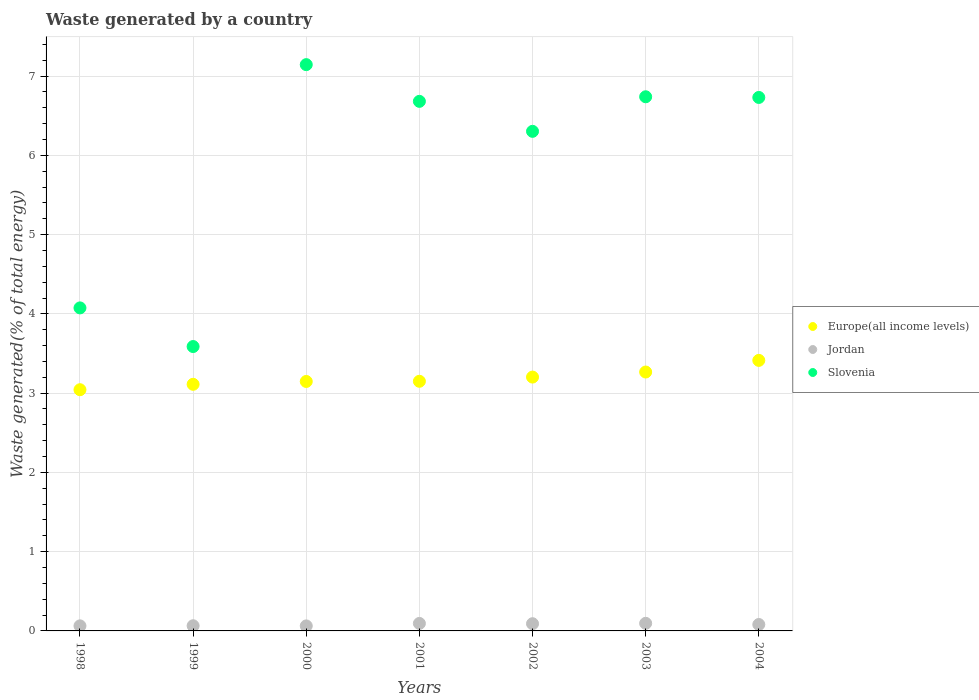Is the number of dotlines equal to the number of legend labels?
Give a very brief answer. Yes. What is the total waste generated in Slovenia in 2002?
Ensure brevity in your answer.  6.3. Across all years, what is the maximum total waste generated in Jordan?
Keep it short and to the point. 0.1. Across all years, what is the minimum total waste generated in Jordan?
Make the answer very short. 0.06. In which year was the total waste generated in Europe(all income levels) maximum?
Provide a short and direct response. 2004. In which year was the total waste generated in Europe(all income levels) minimum?
Give a very brief answer. 1998. What is the total total waste generated in Jordan in the graph?
Offer a terse response. 0.55. What is the difference between the total waste generated in Europe(all income levels) in 1998 and that in 2004?
Your answer should be compact. -0.37. What is the difference between the total waste generated in Europe(all income levels) in 1998 and the total waste generated in Slovenia in 2001?
Provide a short and direct response. -3.64. What is the average total waste generated in Jordan per year?
Your response must be concise. 0.08. In the year 2001, what is the difference between the total waste generated in Jordan and total waste generated in Europe(all income levels)?
Provide a succinct answer. -3.06. What is the ratio of the total waste generated in Slovenia in 2003 to that in 2004?
Provide a succinct answer. 1. Is the total waste generated in Jordan in 1999 less than that in 2003?
Your response must be concise. Yes. What is the difference between the highest and the second highest total waste generated in Jordan?
Your answer should be very brief. 0. What is the difference between the highest and the lowest total waste generated in Europe(all income levels)?
Ensure brevity in your answer.  0.37. In how many years, is the total waste generated in Jordan greater than the average total waste generated in Jordan taken over all years?
Your response must be concise. 4. Is the sum of the total waste generated in Jordan in 2001 and 2003 greater than the maximum total waste generated in Slovenia across all years?
Keep it short and to the point. No. Is it the case that in every year, the sum of the total waste generated in Europe(all income levels) and total waste generated in Slovenia  is greater than the total waste generated in Jordan?
Ensure brevity in your answer.  Yes. Does the total waste generated in Slovenia monotonically increase over the years?
Ensure brevity in your answer.  No. Is the total waste generated in Jordan strictly greater than the total waste generated in Europe(all income levels) over the years?
Keep it short and to the point. No. How many dotlines are there?
Your answer should be compact. 3. What is the difference between two consecutive major ticks on the Y-axis?
Your answer should be compact. 1. Are the values on the major ticks of Y-axis written in scientific E-notation?
Give a very brief answer. No. Does the graph contain any zero values?
Provide a short and direct response. No. Does the graph contain grids?
Make the answer very short. Yes. How many legend labels are there?
Offer a very short reply. 3. How are the legend labels stacked?
Offer a very short reply. Vertical. What is the title of the graph?
Provide a succinct answer. Waste generated by a country. What is the label or title of the Y-axis?
Your response must be concise. Waste generated(% of total energy). What is the Waste generated(% of total energy) of Europe(all income levels) in 1998?
Keep it short and to the point. 3.04. What is the Waste generated(% of total energy) of Jordan in 1998?
Make the answer very short. 0.06. What is the Waste generated(% of total energy) in Slovenia in 1998?
Ensure brevity in your answer.  4.08. What is the Waste generated(% of total energy) in Europe(all income levels) in 1999?
Give a very brief answer. 3.11. What is the Waste generated(% of total energy) in Jordan in 1999?
Keep it short and to the point. 0.07. What is the Waste generated(% of total energy) in Slovenia in 1999?
Make the answer very short. 3.59. What is the Waste generated(% of total energy) in Europe(all income levels) in 2000?
Your answer should be compact. 3.15. What is the Waste generated(% of total energy) of Jordan in 2000?
Ensure brevity in your answer.  0.06. What is the Waste generated(% of total energy) in Slovenia in 2000?
Ensure brevity in your answer.  7.14. What is the Waste generated(% of total energy) of Europe(all income levels) in 2001?
Offer a terse response. 3.15. What is the Waste generated(% of total energy) of Jordan in 2001?
Your response must be concise. 0.09. What is the Waste generated(% of total energy) in Slovenia in 2001?
Your answer should be compact. 6.68. What is the Waste generated(% of total energy) in Europe(all income levels) in 2002?
Provide a short and direct response. 3.2. What is the Waste generated(% of total energy) in Jordan in 2002?
Keep it short and to the point. 0.09. What is the Waste generated(% of total energy) in Slovenia in 2002?
Provide a succinct answer. 6.3. What is the Waste generated(% of total energy) in Europe(all income levels) in 2003?
Offer a very short reply. 3.27. What is the Waste generated(% of total energy) in Jordan in 2003?
Offer a very short reply. 0.1. What is the Waste generated(% of total energy) of Slovenia in 2003?
Give a very brief answer. 6.74. What is the Waste generated(% of total energy) of Europe(all income levels) in 2004?
Your response must be concise. 3.41. What is the Waste generated(% of total energy) of Jordan in 2004?
Your answer should be very brief. 0.08. What is the Waste generated(% of total energy) of Slovenia in 2004?
Provide a short and direct response. 6.73. Across all years, what is the maximum Waste generated(% of total energy) of Europe(all income levels)?
Make the answer very short. 3.41. Across all years, what is the maximum Waste generated(% of total energy) in Jordan?
Ensure brevity in your answer.  0.1. Across all years, what is the maximum Waste generated(% of total energy) in Slovenia?
Your answer should be compact. 7.14. Across all years, what is the minimum Waste generated(% of total energy) in Europe(all income levels)?
Your answer should be very brief. 3.04. Across all years, what is the minimum Waste generated(% of total energy) of Jordan?
Provide a succinct answer. 0.06. Across all years, what is the minimum Waste generated(% of total energy) of Slovenia?
Your answer should be very brief. 3.59. What is the total Waste generated(% of total energy) of Europe(all income levels) in the graph?
Ensure brevity in your answer.  22.33. What is the total Waste generated(% of total energy) of Jordan in the graph?
Your answer should be compact. 0.55. What is the total Waste generated(% of total energy) of Slovenia in the graph?
Your answer should be compact. 41.26. What is the difference between the Waste generated(% of total energy) of Europe(all income levels) in 1998 and that in 1999?
Give a very brief answer. -0.07. What is the difference between the Waste generated(% of total energy) of Jordan in 1998 and that in 1999?
Your response must be concise. -0. What is the difference between the Waste generated(% of total energy) in Slovenia in 1998 and that in 1999?
Your answer should be compact. 0.49. What is the difference between the Waste generated(% of total energy) of Europe(all income levels) in 1998 and that in 2000?
Provide a succinct answer. -0.1. What is the difference between the Waste generated(% of total energy) of Jordan in 1998 and that in 2000?
Your answer should be very brief. 0. What is the difference between the Waste generated(% of total energy) of Slovenia in 1998 and that in 2000?
Your answer should be very brief. -3.07. What is the difference between the Waste generated(% of total energy) of Europe(all income levels) in 1998 and that in 2001?
Provide a short and direct response. -0.11. What is the difference between the Waste generated(% of total energy) in Jordan in 1998 and that in 2001?
Offer a very short reply. -0.03. What is the difference between the Waste generated(% of total energy) of Slovenia in 1998 and that in 2001?
Ensure brevity in your answer.  -2.61. What is the difference between the Waste generated(% of total energy) in Europe(all income levels) in 1998 and that in 2002?
Provide a short and direct response. -0.16. What is the difference between the Waste generated(% of total energy) of Jordan in 1998 and that in 2002?
Provide a succinct answer. -0.03. What is the difference between the Waste generated(% of total energy) in Slovenia in 1998 and that in 2002?
Make the answer very short. -2.23. What is the difference between the Waste generated(% of total energy) of Europe(all income levels) in 1998 and that in 2003?
Offer a very short reply. -0.22. What is the difference between the Waste generated(% of total energy) in Jordan in 1998 and that in 2003?
Make the answer very short. -0.03. What is the difference between the Waste generated(% of total energy) in Slovenia in 1998 and that in 2003?
Keep it short and to the point. -2.66. What is the difference between the Waste generated(% of total energy) of Europe(all income levels) in 1998 and that in 2004?
Provide a succinct answer. -0.37. What is the difference between the Waste generated(% of total energy) of Jordan in 1998 and that in 2004?
Your response must be concise. -0.02. What is the difference between the Waste generated(% of total energy) in Slovenia in 1998 and that in 2004?
Ensure brevity in your answer.  -2.66. What is the difference between the Waste generated(% of total energy) in Europe(all income levels) in 1999 and that in 2000?
Your answer should be compact. -0.04. What is the difference between the Waste generated(% of total energy) of Jordan in 1999 and that in 2000?
Provide a succinct answer. 0. What is the difference between the Waste generated(% of total energy) of Slovenia in 1999 and that in 2000?
Your response must be concise. -3.56. What is the difference between the Waste generated(% of total energy) in Europe(all income levels) in 1999 and that in 2001?
Make the answer very short. -0.04. What is the difference between the Waste generated(% of total energy) in Jordan in 1999 and that in 2001?
Provide a succinct answer. -0.03. What is the difference between the Waste generated(% of total energy) in Slovenia in 1999 and that in 2001?
Offer a terse response. -3.09. What is the difference between the Waste generated(% of total energy) of Europe(all income levels) in 1999 and that in 2002?
Make the answer very short. -0.09. What is the difference between the Waste generated(% of total energy) of Jordan in 1999 and that in 2002?
Offer a terse response. -0.03. What is the difference between the Waste generated(% of total energy) in Slovenia in 1999 and that in 2002?
Give a very brief answer. -2.72. What is the difference between the Waste generated(% of total energy) of Europe(all income levels) in 1999 and that in 2003?
Your response must be concise. -0.15. What is the difference between the Waste generated(% of total energy) of Jordan in 1999 and that in 2003?
Keep it short and to the point. -0.03. What is the difference between the Waste generated(% of total energy) in Slovenia in 1999 and that in 2003?
Provide a succinct answer. -3.15. What is the difference between the Waste generated(% of total energy) in Europe(all income levels) in 1999 and that in 2004?
Your response must be concise. -0.3. What is the difference between the Waste generated(% of total energy) of Jordan in 1999 and that in 2004?
Provide a succinct answer. -0.02. What is the difference between the Waste generated(% of total energy) in Slovenia in 1999 and that in 2004?
Make the answer very short. -3.14. What is the difference between the Waste generated(% of total energy) in Europe(all income levels) in 2000 and that in 2001?
Keep it short and to the point. -0. What is the difference between the Waste generated(% of total energy) in Jordan in 2000 and that in 2001?
Your response must be concise. -0.03. What is the difference between the Waste generated(% of total energy) in Slovenia in 2000 and that in 2001?
Your response must be concise. 0.46. What is the difference between the Waste generated(% of total energy) in Europe(all income levels) in 2000 and that in 2002?
Your response must be concise. -0.06. What is the difference between the Waste generated(% of total energy) of Jordan in 2000 and that in 2002?
Make the answer very short. -0.03. What is the difference between the Waste generated(% of total energy) of Slovenia in 2000 and that in 2002?
Offer a very short reply. 0.84. What is the difference between the Waste generated(% of total energy) of Europe(all income levels) in 2000 and that in 2003?
Ensure brevity in your answer.  -0.12. What is the difference between the Waste generated(% of total energy) in Jordan in 2000 and that in 2003?
Give a very brief answer. -0.03. What is the difference between the Waste generated(% of total energy) in Slovenia in 2000 and that in 2003?
Offer a terse response. 0.41. What is the difference between the Waste generated(% of total energy) in Europe(all income levels) in 2000 and that in 2004?
Provide a succinct answer. -0.27. What is the difference between the Waste generated(% of total energy) in Jordan in 2000 and that in 2004?
Provide a short and direct response. -0.02. What is the difference between the Waste generated(% of total energy) of Slovenia in 2000 and that in 2004?
Your answer should be very brief. 0.41. What is the difference between the Waste generated(% of total energy) of Europe(all income levels) in 2001 and that in 2002?
Keep it short and to the point. -0.05. What is the difference between the Waste generated(% of total energy) of Jordan in 2001 and that in 2002?
Provide a succinct answer. 0. What is the difference between the Waste generated(% of total energy) of Slovenia in 2001 and that in 2002?
Offer a very short reply. 0.38. What is the difference between the Waste generated(% of total energy) of Europe(all income levels) in 2001 and that in 2003?
Provide a succinct answer. -0.12. What is the difference between the Waste generated(% of total energy) in Jordan in 2001 and that in 2003?
Offer a very short reply. -0. What is the difference between the Waste generated(% of total energy) of Slovenia in 2001 and that in 2003?
Provide a short and direct response. -0.06. What is the difference between the Waste generated(% of total energy) in Europe(all income levels) in 2001 and that in 2004?
Offer a very short reply. -0.26. What is the difference between the Waste generated(% of total energy) of Jordan in 2001 and that in 2004?
Your answer should be very brief. 0.01. What is the difference between the Waste generated(% of total energy) of Slovenia in 2001 and that in 2004?
Your response must be concise. -0.05. What is the difference between the Waste generated(% of total energy) of Europe(all income levels) in 2002 and that in 2003?
Give a very brief answer. -0.06. What is the difference between the Waste generated(% of total energy) in Jordan in 2002 and that in 2003?
Make the answer very short. -0. What is the difference between the Waste generated(% of total energy) of Slovenia in 2002 and that in 2003?
Your answer should be very brief. -0.44. What is the difference between the Waste generated(% of total energy) of Europe(all income levels) in 2002 and that in 2004?
Provide a succinct answer. -0.21. What is the difference between the Waste generated(% of total energy) in Slovenia in 2002 and that in 2004?
Your answer should be very brief. -0.43. What is the difference between the Waste generated(% of total energy) of Europe(all income levels) in 2003 and that in 2004?
Offer a very short reply. -0.15. What is the difference between the Waste generated(% of total energy) of Jordan in 2003 and that in 2004?
Your answer should be compact. 0.01. What is the difference between the Waste generated(% of total energy) of Slovenia in 2003 and that in 2004?
Offer a terse response. 0.01. What is the difference between the Waste generated(% of total energy) in Europe(all income levels) in 1998 and the Waste generated(% of total energy) in Jordan in 1999?
Offer a very short reply. 2.98. What is the difference between the Waste generated(% of total energy) in Europe(all income levels) in 1998 and the Waste generated(% of total energy) in Slovenia in 1999?
Provide a succinct answer. -0.54. What is the difference between the Waste generated(% of total energy) of Jordan in 1998 and the Waste generated(% of total energy) of Slovenia in 1999?
Your response must be concise. -3.52. What is the difference between the Waste generated(% of total energy) of Europe(all income levels) in 1998 and the Waste generated(% of total energy) of Jordan in 2000?
Ensure brevity in your answer.  2.98. What is the difference between the Waste generated(% of total energy) of Europe(all income levels) in 1998 and the Waste generated(% of total energy) of Slovenia in 2000?
Give a very brief answer. -4.1. What is the difference between the Waste generated(% of total energy) of Jordan in 1998 and the Waste generated(% of total energy) of Slovenia in 2000?
Give a very brief answer. -7.08. What is the difference between the Waste generated(% of total energy) of Europe(all income levels) in 1998 and the Waste generated(% of total energy) of Jordan in 2001?
Provide a short and direct response. 2.95. What is the difference between the Waste generated(% of total energy) in Europe(all income levels) in 1998 and the Waste generated(% of total energy) in Slovenia in 2001?
Your response must be concise. -3.64. What is the difference between the Waste generated(% of total energy) of Jordan in 1998 and the Waste generated(% of total energy) of Slovenia in 2001?
Provide a succinct answer. -6.62. What is the difference between the Waste generated(% of total energy) in Europe(all income levels) in 1998 and the Waste generated(% of total energy) in Jordan in 2002?
Your response must be concise. 2.95. What is the difference between the Waste generated(% of total energy) of Europe(all income levels) in 1998 and the Waste generated(% of total energy) of Slovenia in 2002?
Give a very brief answer. -3.26. What is the difference between the Waste generated(% of total energy) in Jordan in 1998 and the Waste generated(% of total energy) in Slovenia in 2002?
Your response must be concise. -6.24. What is the difference between the Waste generated(% of total energy) of Europe(all income levels) in 1998 and the Waste generated(% of total energy) of Jordan in 2003?
Offer a very short reply. 2.95. What is the difference between the Waste generated(% of total energy) of Europe(all income levels) in 1998 and the Waste generated(% of total energy) of Slovenia in 2003?
Make the answer very short. -3.7. What is the difference between the Waste generated(% of total energy) in Jordan in 1998 and the Waste generated(% of total energy) in Slovenia in 2003?
Keep it short and to the point. -6.68. What is the difference between the Waste generated(% of total energy) in Europe(all income levels) in 1998 and the Waste generated(% of total energy) in Jordan in 2004?
Your response must be concise. 2.96. What is the difference between the Waste generated(% of total energy) in Europe(all income levels) in 1998 and the Waste generated(% of total energy) in Slovenia in 2004?
Your answer should be very brief. -3.69. What is the difference between the Waste generated(% of total energy) in Jordan in 1998 and the Waste generated(% of total energy) in Slovenia in 2004?
Keep it short and to the point. -6.67. What is the difference between the Waste generated(% of total energy) of Europe(all income levels) in 1999 and the Waste generated(% of total energy) of Jordan in 2000?
Make the answer very short. 3.05. What is the difference between the Waste generated(% of total energy) in Europe(all income levels) in 1999 and the Waste generated(% of total energy) in Slovenia in 2000?
Your answer should be very brief. -4.03. What is the difference between the Waste generated(% of total energy) in Jordan in 1999 and the Waste generated(% of total energy) in Slovenia in 2000?
Make the answer very short. -7.08. What is the difference between the Waste generated(% of total energy) in Europe(all income levels) in 1999 and the Waste generated(% of total energy) in Jordan in 2001?
Your answer should be very brief. 3.02. What is the difference between the Waste generated(% of total energy) in Europe(all income levels) in 1999 and the Waste generated(% of total energy) in Slovenia in 2001?
Offer a very short reply. -3.57. What is the difference between the Waste generated(% of total energy) in Jordan in 1999 and the Waste generated(% of total energy) in Slovenia in 2001?
Provide a short and direct response. -6.62. What is the difference between the Waste generated(% of total energy) of Europe(all income levels) in 1999 and the Waste generated(% of total energy) of Jordan in 2002?
Provide a short and direct response. 3.02. What is the difference between the Waste generated(% of total energy) of Europe(all income levels) in 1999 and the Waste generated(% of total energy) of Slovenia in 2002?
Ensure brevity in your answer.  -3.19. What is the difference between the Waste generated(% of total energy) of Jordan in 1999 and the Waste generated(% of total energy) of Slovenia in 2002?
Offer a very short reply. -6.24. What is the difference between the Waste generated(% of total energy) in Europe(all income levels) in 1999 and the Waste generated(% of total energy) in Jordan in 2003?
Give a very brief answer. 3.02. What is the difference between the Waste generated(% of total energy) of Europe(all income levels) in 1999 and the Waste generated(% of total energy) of Slovenia in 2003?
Give a very brief answer. -3.63. What is the difference between the Waste generated(% of total energy) of Jordan in 1999 and the Waste generated(% of total energy) of Slovenia in 2003?
Ensure brevity in your answer.  -6.67. What is the difference between the Waste generated(% of total energy) in Europe(all income levels) in 1999 and the Waste generated(% of total energy) in Jordan in 2004?
Provide a short and direct response. 3.03. What is the difference between the Waste generated(% of total energy) in Europe(all income levels) in 1999 and the Waste generated(% of total energy) in Slovenia in 2004?
Offer a terse response. -3.62. What is the difference between the Waste generated(% of total energy) in Jordan in 1999 and the Waste generated(% of total energy) in Slovenia in 2004?
Your response must be concise. -6.67. What is the difference between the Waste generated(% of total energy) in Europe(all income levels) in 2000 and the Waste generated(% of total energy) in Jordan in 2001?
Provide a succinct answer. 3.05. What is the difference between the Waste generated(% of total energy) of Europe(all income levels) in 2000 and the Waste generated(% of total energy) of Slovenia in 2001?
Your answer should be compact. -3.53. What is the difference between the Waste generated(% of total energy) in Jordan in 2000 and the Waste generated(% of total energy) in Slovenia in 2001?
Ensure brevity in your answer.  -6.62. What is the difference between the Waste generated(% of total energy) in Europe(all income levels) in 2000 and the Waste generated(% of total energy) in Jordan in 2002?
Your answer should be compact. 3.06. What is the difference between the Waste generated(% of total energy) of Europe(all income levels) in 2000 and the Waste generated(% of total energy) of Slovenia in 2002?
Keep it short and to the point. -3.16. What is the difference between the Waste generated(% of total energy) in Jordan in 2000 and the Waste generated(% of total energy) in Slovenia in 2002?
Provide a succinct answer. -6.24. What is the difference between the Waste generated(% of total energy) in Europe(all income levels) in 2000 and the Waste generated(% of total energy) in Jordan in 2003?
Provide a short and direct response. 3.05. What is the difference between the Waste generated(% of total energy) of Europe(all income levels) in 2000 and the Waste generated(% of total energy) of Slovenia in 2003?
Make the answer very short. -3.59. What is the difference between the Waste generated(% of total energy) of Jordan in 2000 and the Waste generated(% of total energy) of Slovenia in 2003?
Make the answer very short. -6.68. What is the difference between the Waste generated(% of total energy) of Europe(all income levels) in 2000 and the Waste generated(% of total energy) of Jordan in 2004?
Your answer should be compact. 3.07. What is the difference between the Waste generated(% of total energy) in Europe(all income levels) in 2000 and the Waste generated(% of total energy) in Slovenia in 2004?
Your response must be concise. -3.58. What is the difference between the Waste generated(% of total energy) in Jordan in 2000 and the Waste generated(% of total energy) in Slovenia in 2004?
Offer a very short reply. -6.67. What is the difference between the Waste generated(% of total energy) in Europe(all income levels) in 2001 and the Waste generated(% of total energy) in Jordan in 2002?
Provide a succinct answer. 3.06. What is the difference between the Waste generated(% of total energy) in Europe(all income levels) in 2001 and the Waste generated(% of total energy) in Slovenia in 2002?
Provide a short and direct response. -3.15. What is the difference between the Waste generated(% of total energy) in Jordan in 2001 and the Waste generated(% of total energy) in Slovenia in 2002?
Make the answer very short. -6.21. What is the difference between the Waste generated(% of total energy) in Europe(all income levels) in 2001 and the Waste generated(% of total energy) in Jordan in 2003?
Provide a short and direct response. 3.05. What is the difference between the Waste generated(% of total energy) in Europe(all income levels) in 2001 and the Waste generated(% of total energy) in Slovenia in 2003?
Give a very brief answer. -3.59. What is the difference between the Waste generated(% of total energy) in Jordan in 2001 and the Waste generated(% of total energy) in Slovenia in 2003?
Offer a terse response. -6.64. What is the difference between the Waste generated(% of total energy) in Europe(all income levels) in 2001 and the Waste generated(% of total energy) in Jordan in 2004?
Keep it short and to the point. 3.07. What is the difference between the Waste generated(% of total energy) in Europe(all income levels) in 2001 and the Waste generated(% of total energy) in Slovenia in 2004?
Offer a very short reply. -3.58. What is the difference between the Waste generated(% of total energy) in Jordan in 2001 and the Waste generated(% of total energy) in Slovenia in 2004?
Keep it short and to the point. -6.64. What is the difference between the Waste generated(% of total energy) in Europe(all income levels) in 2002 and the Waste generated(% of total energy) in Jordan in 2003?
Your answer should be compact. 3.11. What is the difference between the Waste generated(% of total energy) in Europe(all income levels) in 2002 and the Waste generated(% of total energy) in Slovenia in 2003?
Keep it short and to the point. -3.54. What is the difference between the Waste generated(% of total energy) in Jordan in 2002 and the Waste generated(% of total energy) in Slovenia in 2003?
Make the answer very short. -6.65. What is the difference between the Waste generated(% of total energy) in Europe(all income levels) in 2002 and the Waste generated(% of total energy) in Jordan in 2004?
Provide a short and direct response. 3.12. What is the difference between the Waste generated(% of total energy) in Europe(all income levels) in 2002 and the Waste generated(% of total energy) in Slovenia in 2004?
Offer a very short reply. -3.53. What is the difference between the Waste generated(% of total energy) of Jordan in 2002 and the Waste generated(% of total energy) of Slovenia in 2004?
Your answer should be very brief. -6.64. What is the difference between the Waste generated(% of total energy) of Europe(all income levels) in 2003 and the Waste generated(% of total energy) of Jordan in 2004?
Make the answer very short. 3.19. What is the difference between the Waste generated(% of total energy) of Europe(all income levels) in 2003 and the Waste generated(% of total energy) of Slovenia in 2004?
Keep it short and to the point. -3.46. What is the difference between the Waste generated(% of total energy) of Jordan in 2003 and the Waste generated(% of total energy) of Slovenia in 2004?
Provide a succinct answer. -6.63. What is the average Waste generated(% of total energy) in Europe(all income levels) per year?
Keep it short and to the point. 3.19. What is the average Waste generated(% of total energy) of Jordan per year?
Provide a succinct answer. 0.08. What is the average Waste generated(% of total energy) in Slovenia per year?
Provide a short and direct response. 5.89. In the year 1998, what is the difference between the Waste generated(% of total energy) in Europe(all income levels) and Waste generated(% of total energy) in Jordan?
Make the answer very short. 2.98. In the year 1998, what is the difference between the Waste generated(% of total energy) of Europe(all income levels) and Waste generated(% of total energy) of Slovenia?
Provide a short and direct response. -1.03. In the year 1998, what is the difference between the Waste generated(% of total energy) in Jordan and Waste generated(% of total energy) in Slovenia?
Provide a short and direct response. -4.01. In the year 1999, what is the difference between the Waste generated(% of total energy) of Europe(all income levels) and Waste generated(% of total energy) of Jordan?
Provide a succinct answer. 3.05. In the year 1999, what is the difference between the Waste generated(% of total energy) of Europe(all income levels) and Waste generated(% of total energy) of Slovenia?
Your response must be concise. -0.48. In the year 1999, what is the difference between the Waste generated(% of total energy) of Jordan and Waste generated(% of total energy) of Slovenia?
Offer a terse response. -3.52. In the year 2000, what is the difference between the Waste generated(% of total energy) of Europe(all income levels) and Waste generated(% of total energy) of Jordan?
Give a very brief answer. 3.08. In the year 2000, what is the difference between the Waste generated(% of total energy) in Europe(all income levels) and Waste generated(% of total energy) in Slovenia?
Your response must be concise. -4. In the year 2000, what is the difference between the Waste generated(% of total energy) in Jordan and Waste generated(% of total energy) in Slovenia?
Offer a terse response. -7.08. In the year 2001, what is the difference between the Waste generated(% of total energy) of Europe(all income levels) and Waste generated(% of total energy) of Jordan?
Provide a short and direct response. 3.06. In the year 2001, what is the difference between the Waste generated(% of total energy) in Europe(all income levels) and Waste generated(% of total energy) in Slovenia?
Provide a short and direct response. -3.53. In the year 2001, what is the difference between the Waste generated(% of total energy) in Jordan and Waste generated(% of total energy) in Slovenia?
Offer a terse response. -6.59. In the year 2002, what is the difference between the Waste generated(% of total energy) of Europe(all income levels) and Waste generated(% of total energy) of Jordan?
Provide a succinct answer. 3.11. In the year 2002, what is the difference between the Waste generated(% of total energy) of Europe(all income levels) and Waste generated(% of total energy) of Slovenia?
Offer a terse response. -3.1. In the year 2002, what is the difference between the Waste generated(% of total energy) in Jordan and Waste generated(% of total energy) in Slovenia?
Keep it short and to the point. -6.21. In the year 2003, what is the difference between the Waste generated(% of total energy) of Europe(all income levels) and Waste generated(% of total energy) of Jordan?
Make the answer very short. 3.17. In the year 2003, what is the difference between the Waste generated(% of total energy) of Europe(all income levels) and Waste generated(% of total energy) of Slovenia?
Provide a succinct answer. -3.47. In the year 2003, what is the difference between the Waste generated(% of total energy) of Jordan and Waste generated(% of total energy) of Slovenia?
Keep it short and to the point. -6.64. In the year 2004, what is the difference between the Waste generated(% of total energy) of Europe(all income levels) and Waste generated(% of total energy) of Jordan?
Give a very brief answer. 3.33. In the year 2004, what is the difference between the Waste generated(% of total energy) in Europe(all income levels) and Waste generated(% of total energy) in Slovenia?
Offer a terse response. -3.32. In the year 2004, what is the difference between the Waste generated(% of total energy) in Jordan and Waste generated(% of total energy) in Slovenia?
Your answer should be compact. -6.65. What is the ratio of the Waste generated(% of total energy) of Europe(all income levels) in 1998 to that in 1999?
Your answer should be very brief. 0.98. What is the ratio of the Waste generated(% of total energy) in Jordan in 1998 to that in 1999?
Offer a terse response. 0.98. What is the ratio of the Waste generated(% of total energy) of Slovenia in 1998 to that in 1999?
Your answer should be very brief. 1.14. What is the ratio of the Waste generated(% of total energy) in Europe(all income levels) in 1998 to that in 2000?
Your answer should be compact. 0.97. What is the ratio of the Waste generated(% of total energy) of Jordan in 1998 to that in 2000?
Keep it short and to the point. 1.01. What is the ratio of the Waste generated(% of total energy) of Slovenia in 1998 to that in 2000?
Ensure brevity in your answer.  0.57. What is the ratio of the Waste generated(% of total energy) in Europe(all income levels) in 1998 to that in 2001?
Your response must be concise. 0.97. What is the ratio of the Waste generated(% of total energy) in Jordan in 1998 to that in 2001?
Provide a succinct answer. 0.68. What is the ratio of the Waste generated(% of total energy) of Slovenia in 1998 to that in 2001?
Provide a short and direct response. 0.61. What is the ratio of the Waste generated(% of total energy) in Europe(all income levels) in 1998 to that in 2002?
Offer a terse response. 0.95. What is the ratio of the Waste generated(% of total energy) in Jordan in 1998 to that in 2002?
Your answer should be compact. 0.7. What is the ratio of the Waste generated(% of total energy) of Slovenia in 1998 to that in 2002?
Offer a very short reply. 0.65. What is the ratio of the Waste generated(% of total energy) in Europe(all income levels) in 1998 to that in 2003?
Your response must be concise. 0.93. What is the ratio of the Waste generated(% of total energy) in Jordan in 1998 to that in 2003?
Your response must be concise. 0.67. What is the ratio of the Waste generated(% of total energy) in Slovenia in 1998 to that in 2003?
Keep it short and to the point. 0.6. What is the ratio of the Waste generated(% of total energy) in Europe(all income levels) in 1998 to that in 2004?
Offer a very short reply. 0.89. What is the ratio of the Waste generated(% of total energy) of Jordan in 1998 to that in 2004?
Ensure brevity in your answer.  0.79. What is the ratio of the Waste generated(% of total energy) of Slovenia in 1998 to that in 2004?
Your answer should be compact. 0.61. What is the ratio of the Waste generated(% of total energy) in Jordan in 1999 to that in 2000?
Provide a short and direct response. 1.03. What is the ratio of the Waste generated(% of total energy) of Slovenia in 1999 to that in 2000?
Keep it short and to the point. 0.5. What is the ratio of the Waste generated(% of total energy) of Europe(all income levels) in 1999 to that in 2001?
Make the answer very short. 0.99. What is the ratio of the Waste generated(% of total energy) in Jordan in 1999 to that in 2001?
Provide a succinct answer. 0.69. What is the ratio of the Waste generated(% of total energy) of Slovenia in 1999 to that in 2001?
Your response must be concise. 0.54. What is the ratio of the Waste generated(% of total energy) of Europe(all income levels) in 1999 to that in 2002?
Your answer should be very brief. 0.97. What is the ratio of the Waste generated(% of total energy) of Jordan in 1999 to that in 2002?
Your answer should be compact. 0.72. What is the ratio of the Waste generated(% of total energy) in Slovenia in 1999 to that in 2002?
Make the answer very short. 0.57. What is the ratio of the Waste generated(% of total energy) in Europe(all income levels) in 1999 to that in 2003?
Your answer should be very brief. 0.95. What is the ratio of the Waste generated(% of total energy) in Jordan in 1999 to that in 2003?
Offer a terse response. 0.68. What is the ratio of the Waste generated(% of total energy) of Slovenia in 1999 to that in 2003?
Provide a short and direct response. 0.53. What is the ratio of the Waste generated(% of total energy) of Europe(all income levels) in 1999 to that in 2004?
Provide a succinct answer. 0.91. What is the ratio of the Waste generated(% of total energy) of Jordan in 1999 to that in 2004?
Your answer should be very brief. 0.8. What is the ratio of the Waste generated(% of total energy) in Slovenia in 1999 to that in 2004?
Give a very brief answer. 0.53. What is the ratio of the Waste generated(% of total energy) in Jordan in 2000 to that in 2001?
Ensure brevity in your answer.  0.67. What is the ratio of the Waste generated(% of total energy) of Slovenia in 2000 to that in 2001?
Offer a terse response. 1.07. What is the ratio of the Waste generated(% of total energy) of Europe(all income levels) in 2000 to that in 2002?
Your answer should be very brief. 0.98. What is the ratio of the Waste generated(% of total energy) in Jordan in 2000 to that in 2002?
Provide a succinct answer. 0.7. What is the ratio of the Waste generated(% of total energy) in Slovenia in 2000 to that in 2002?
Provide a succinct answer. 1.13. What is the ratio of the Waste generated(% of total energy) of Europe(all income levels) in 2000 to that in 2003?
Keep it short and to the point. 0.96. What is the ratio of the Waste generated(% of total energy) of Jordan in 2000 to that in 2003?
Ensure brevity in your answer.  0.66. What is the ratio of the Waste generated(% of total energy) of Slovenia in 2000 to that in 2003?
Provide a succinct answer. 1.06. What is the ratio of the Waste generated(% of total energy) in Europe(all income levels) in 2000 to that in 2004?
Give a very brief answer. 0.92. What is the ratio of the Waste generated(% of total energy) of Jordan in 2000 to that in 2004?
Provide a succinct answer. 0.78. What is the ratio of the Waste generated(% of total energy) of Slovenia in 2000 to that in 2004?
Offer a terse response. 1.06. What is the ratio of the Waste generated(% of total energy) in Europe(all income levels) in 2001 to that in 2002?
Your answer should be very brief. 0.98. What is the ratio of the Waste generated(% of total energy) in Jordan in 2001 to that in 2002?
Keep it short and to the point. 1.04. What is the ratio of the Waste generated(% of total energy) in Slovenia in 2001 to that in 2002?
Your answer should be compact. 1.06. What is the ratio of the Waste generated(% of total energy) of Europe(all income levels) in 2001 to that in 2003?
Your answer should be very brief. 0.96. What is the ratio of the Waste generated(% of total energy) of Jordan in 2001 to that in 2003?
Provide a succinct answer. 0.99. What is the ratio of the Waste generated(% of total energy) in Europe(all income levels) in 2001 to that in 2004?
Offer a very short reply. 0.92. What is the ratio of the Waste generated(% of total energy) in Jordan in 2001 to that in 2004?
Make the answer very short. 1.17. What is the ratio of the Waste generated(% of total energy) of Slovenia in 2001 to that in 2004?
Your answer should be compact. 0.99. What is the ratio of the Waste generated(% of total energy) in Europe(all income levels) in 2002 to that in 2003?
Your response must be concise. 0.98. What is the ratio of the Waste generated(% of total energy) of Jordan in 2002 to that in 2003?
Give a very brief answer. 0.95. What is the ratio of the Waste generated(% of total energy) of Slovenia in 2002 to that in 2003?
Give a very brief answer. 0.94. What is the ratio of the Waste generated(% of total energy) in Europe(all income levels) in 2002 to that in 2004?
Your response must be concise. 0.94. What is the ratio of the Waste generated(% of total energy) of Jordan in 2002 to that in 2004?
Your answer should be very brief. 1.12. What is the ratio of the Waste generated(% of total energy) of Slovenia in 2002 to that in 2004?
Provide a short and direct response. 0.94. What is the ratio of the Waste generated(% of total energy) in Jordan in 2003 to that in 2004?
Provide a succinct answer. 1.18. What is the difference between the highest and the second highest Waste generated(% of total energy) of Europe(all income levels)?
Offer a very short reply. 0.15. What is the difference between the highest and the second highest Waste generated(% of total energy) of Jordan?
Give a very brief answer. 0. What is the difference between the highest and the second highest Waste generated(% of total energy) in Slovenia?
Keep it short and to the point. 0.41. What is the difference between the highest and the lowest Waste generated(% of total energy) in Europe(all income levels)?
Provide a succinct answer. 0.37. What is the difference between the highest and the lowest Waste generated(% of total energy) in Jordan?
Your answer should be very brief. 0.03. What is the difference between the highest and the lowest Waste generated(% of total energy) in Slovenia?
Offer a terse response. 3.56. 